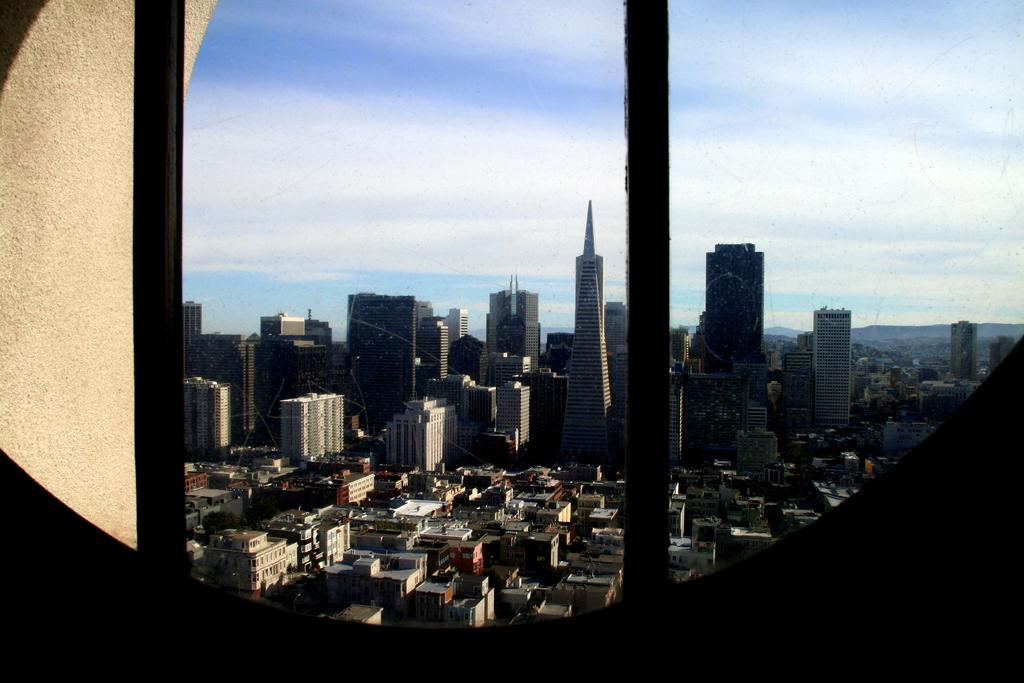What type of structures can be seen in the image? There are buildings in the image. What is the condition of the sky in the image? The sky is clear in the image. What type of barrier is visible in the image? There is a wall visible in the image. What type of skin condition can be seen on the buildings in the image? There is no mention of any skin condition in the image, as the subject is buildings, not living organisms. 